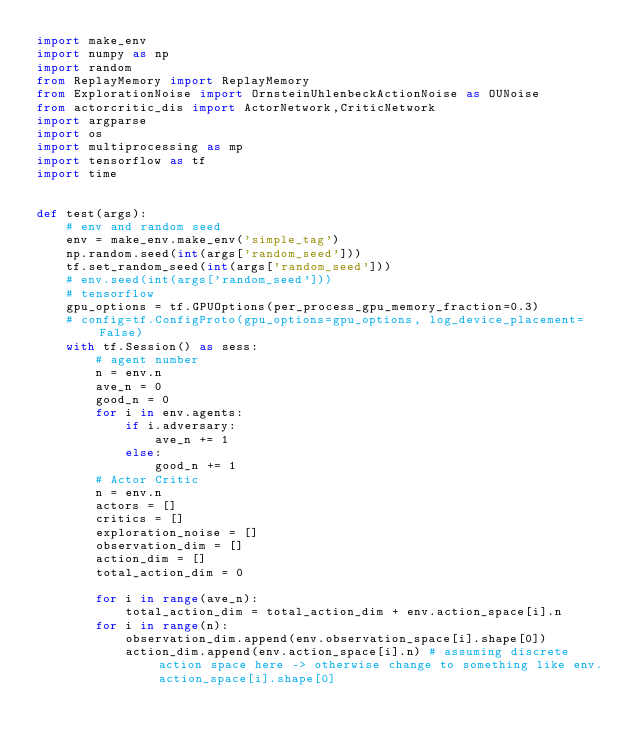<code> <loc_0><loc_0><loc_500><loc_500><_Python_>import make_env
import numpy as np
import random
from ReplayMemory import ReplayMemory
from ExplorationNoise import OrnsteinUhlenbeckActionNoise as OUNoise
from actorcritic_dis import ActorNetwork,CriticNetwork
import argparse
import os
import multiprocessing as mp
import tensorflow as tf
import time


def test(args):
    # env and random seed
    env = make_env.make_env('simple_tag')
    np.random.seed(int(args['random_seed']))
    tf.set_random_seed(int(args['random_seed']))
    # env.seed(int(args['random_seed']))
    # tensorflow
    gpu_options = tf.GPUOptions(per_process_gpu_memory_fraction=0.3)
    # config=tf.ConfigProto(gpu_options=gpu_options, log_device_placement=False)
    with tf.Session() as sess:
        # agent number
        n = env.n
        ave_n = 0
        good_n = 0
        for i in env.agents:
            if i.adversary:
                ave_n += 1
            else:
                good_n += 1
        # Actor Critic
        n = env.n
        actors = []
        critics = []
        exploration_noise = []
        observation_dim = []
        action_dim = []
        total_action_dim = 0

        for i in range(ave_n):
            total_action_dim = total_action_dim + env.action_space[i].n
        for i in range(n):
            observation_dim.append(env.observation_space[i].shape[0])
            action_dim.append(env.action_space[i].n) # assuming discrete action space here -> otherwise change to something like env.action_space[i].shape[0]</code> 